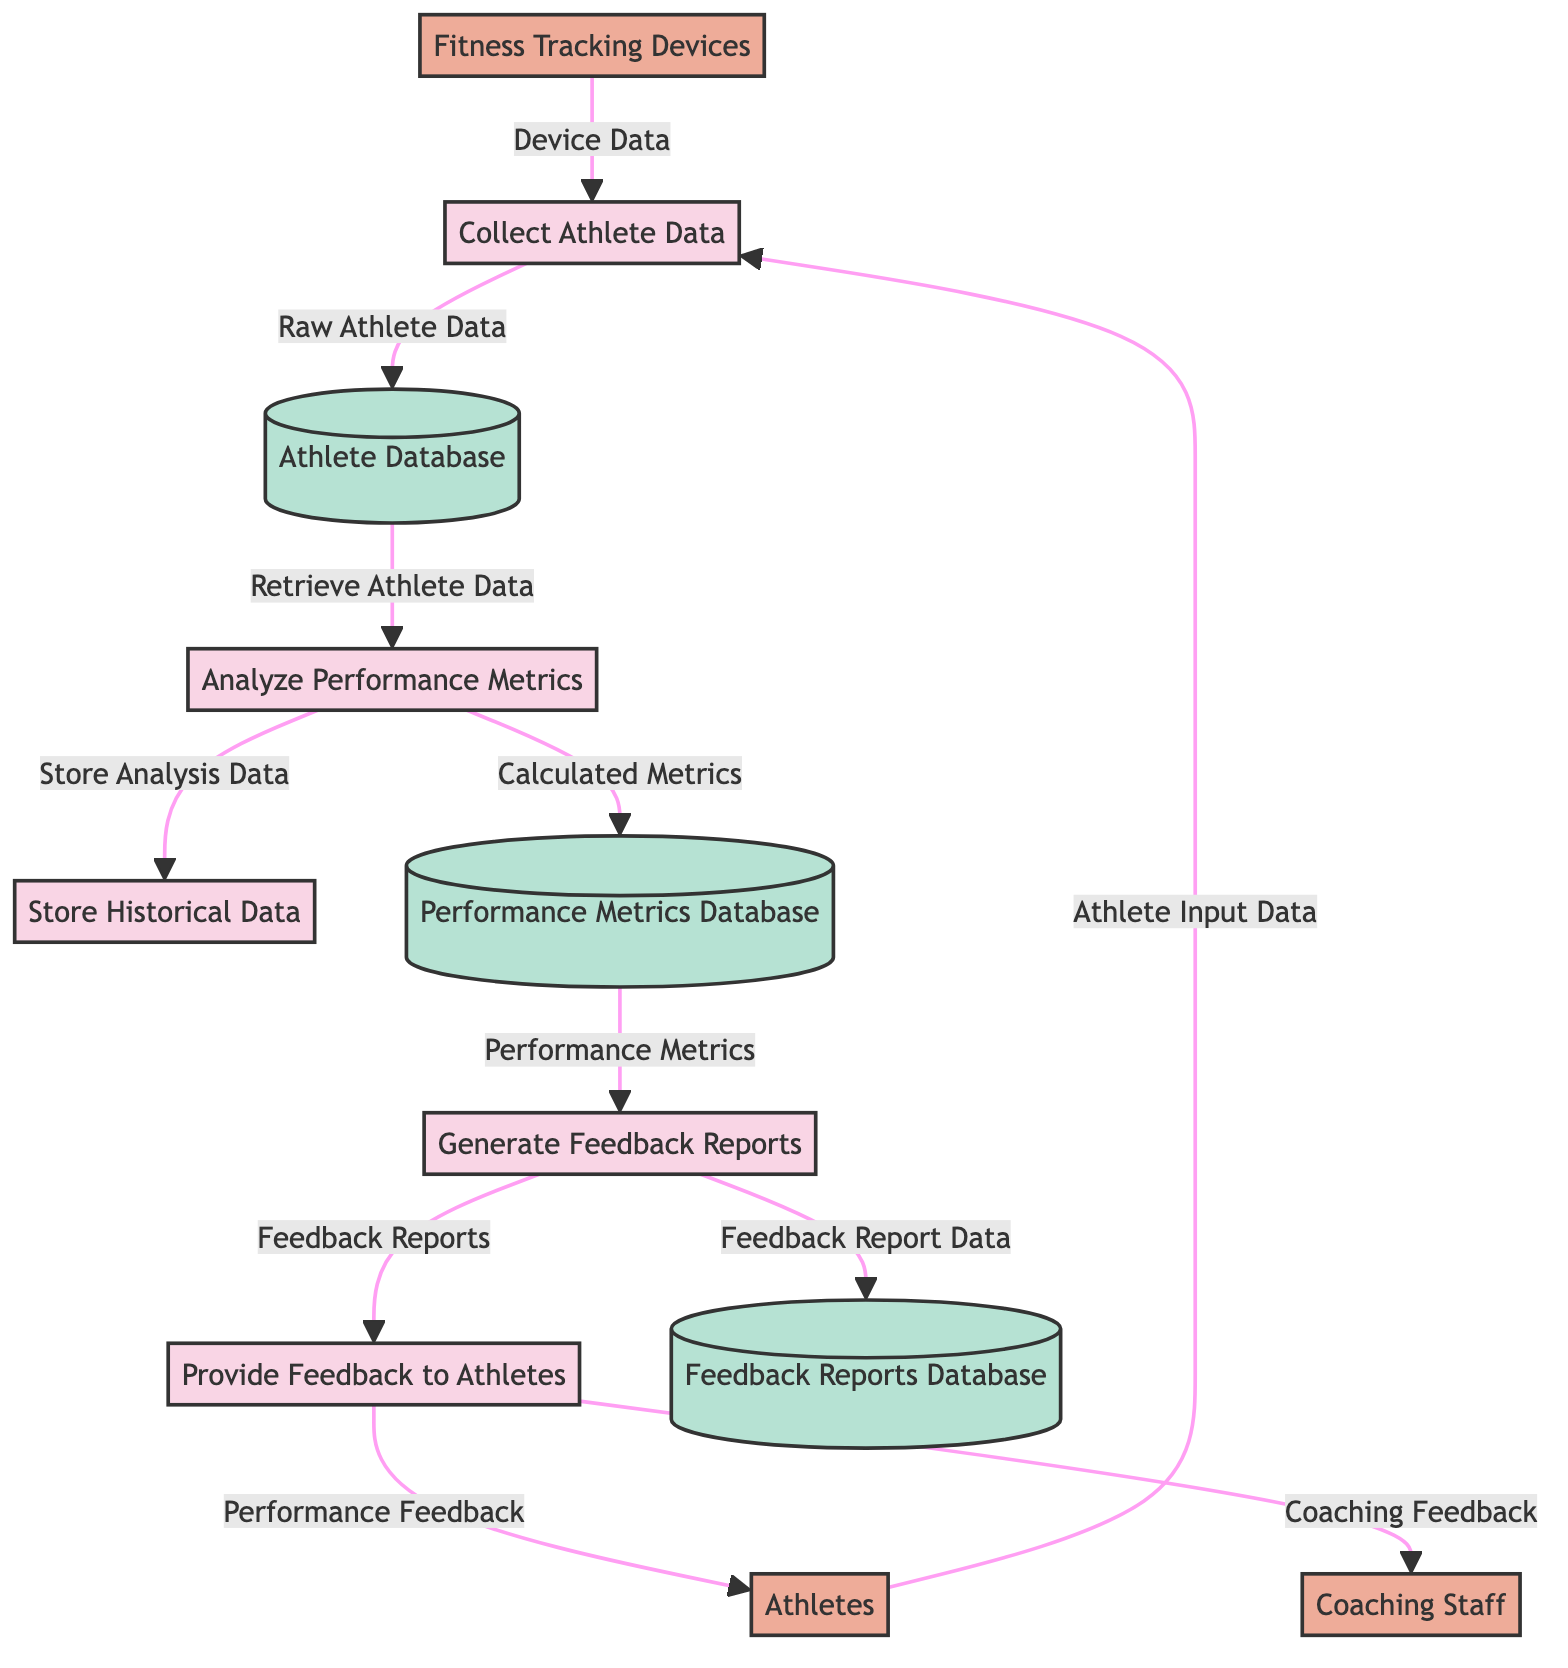What are the external entities in the diagram? The diagram contains three external entities: athletes, coaching staff, and fitness tracking devices. This is derived from identifying the nodes labeled as external entities in the diagram.
Answer: Athletes, Coaching Staff, Fitness Tracking Devices How many processes are present in the diagram? There are five processes visible in the diagram, as indicated by the distinct nodes labeled as processes.
Answer: 5 What data flows from the "Analyze Performance Metrics" process to the "Store Historical Data" process? The flow from the "Analyze Performance Metrics" process to "Store Historical Data" is labeled as "Store Analysis Data". This is based on the directional line showing data movement between process nodes.
Answer: Store Analysis Data Which data store receives the "Feedback Report Data"? The "Feedback Reports Database" is the data store that receives the "Feedback Report Data", as indicated by the arrow leading from the "Generate Feedback Reports" process to this data store.
Answer: Feedback Reports Database What information is given to athletes after feedback is generated? The information provided to athletes after feedback is generated is "Performance Feedback" which flows from the "Provide Feedback to Athletes" process to the athletes.
Answer: Performance Feedback Which process retrieves athlete data from the Athlete Database? The process that retrieves athlete data from the Athlete Database is "Analyze Performance Metrics", as shown by the data flow directed from the Athlete Database to the Analyze Performance Metrics process.
Answer: Analyze Performance Metrics What type of data do fitness tracking devices supply? Fitness tracking devices supply "Device Data" to the "Collect Athlete Data" process, which is clear from the connecting arrow labeled accordingly.
Answer: Device Data From which process does the "Performance Metrics" flow originate? The "Performance Metrics" flow originates from the "Analyze Performance Metrics" process, as seen in the flow directed towards the "Generate Feedback Reports" process.
Answer: Analyze Performance Metrics How many data stores are listed in the diagram? The diagram lists three data stores: Athlete Database, Performance Metrics Database, and Feedback Reports Database. This is determined by counting the nodes identified as data stores.
Answer: 3 